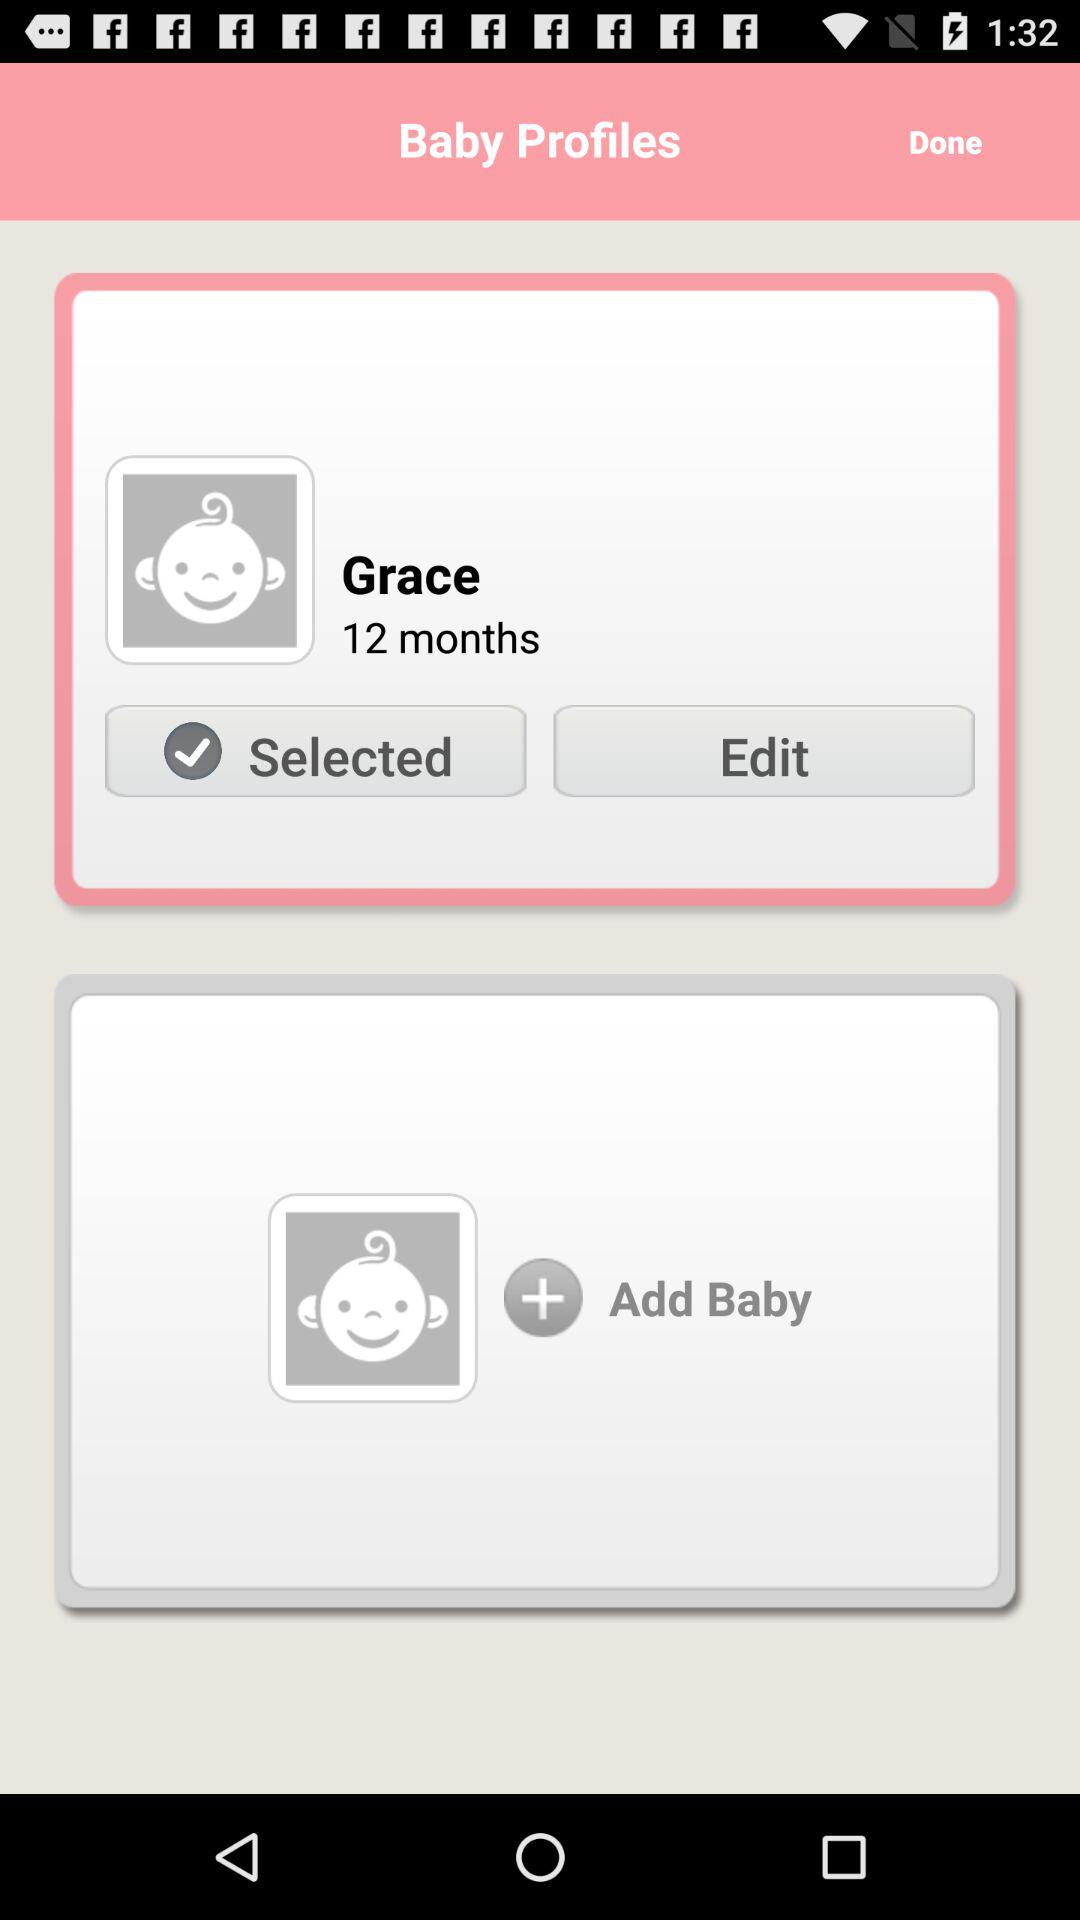What is the name of the baby? The name of the baby is Grace. 